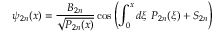Convert formula to latex. <formula><loc_0><loc_0><loc_500><loc_500>\psi _ { 2 n } ( x ) = \frac { B _ { 2 n } } { \sqrt { P _ { 2 n } ( x ) } } \cos \left ( \int _ { 0 } ^ { x } d \xi \ P _ { 2 n } ( \xi ) + S _ { 2 n } \right )</formula> 